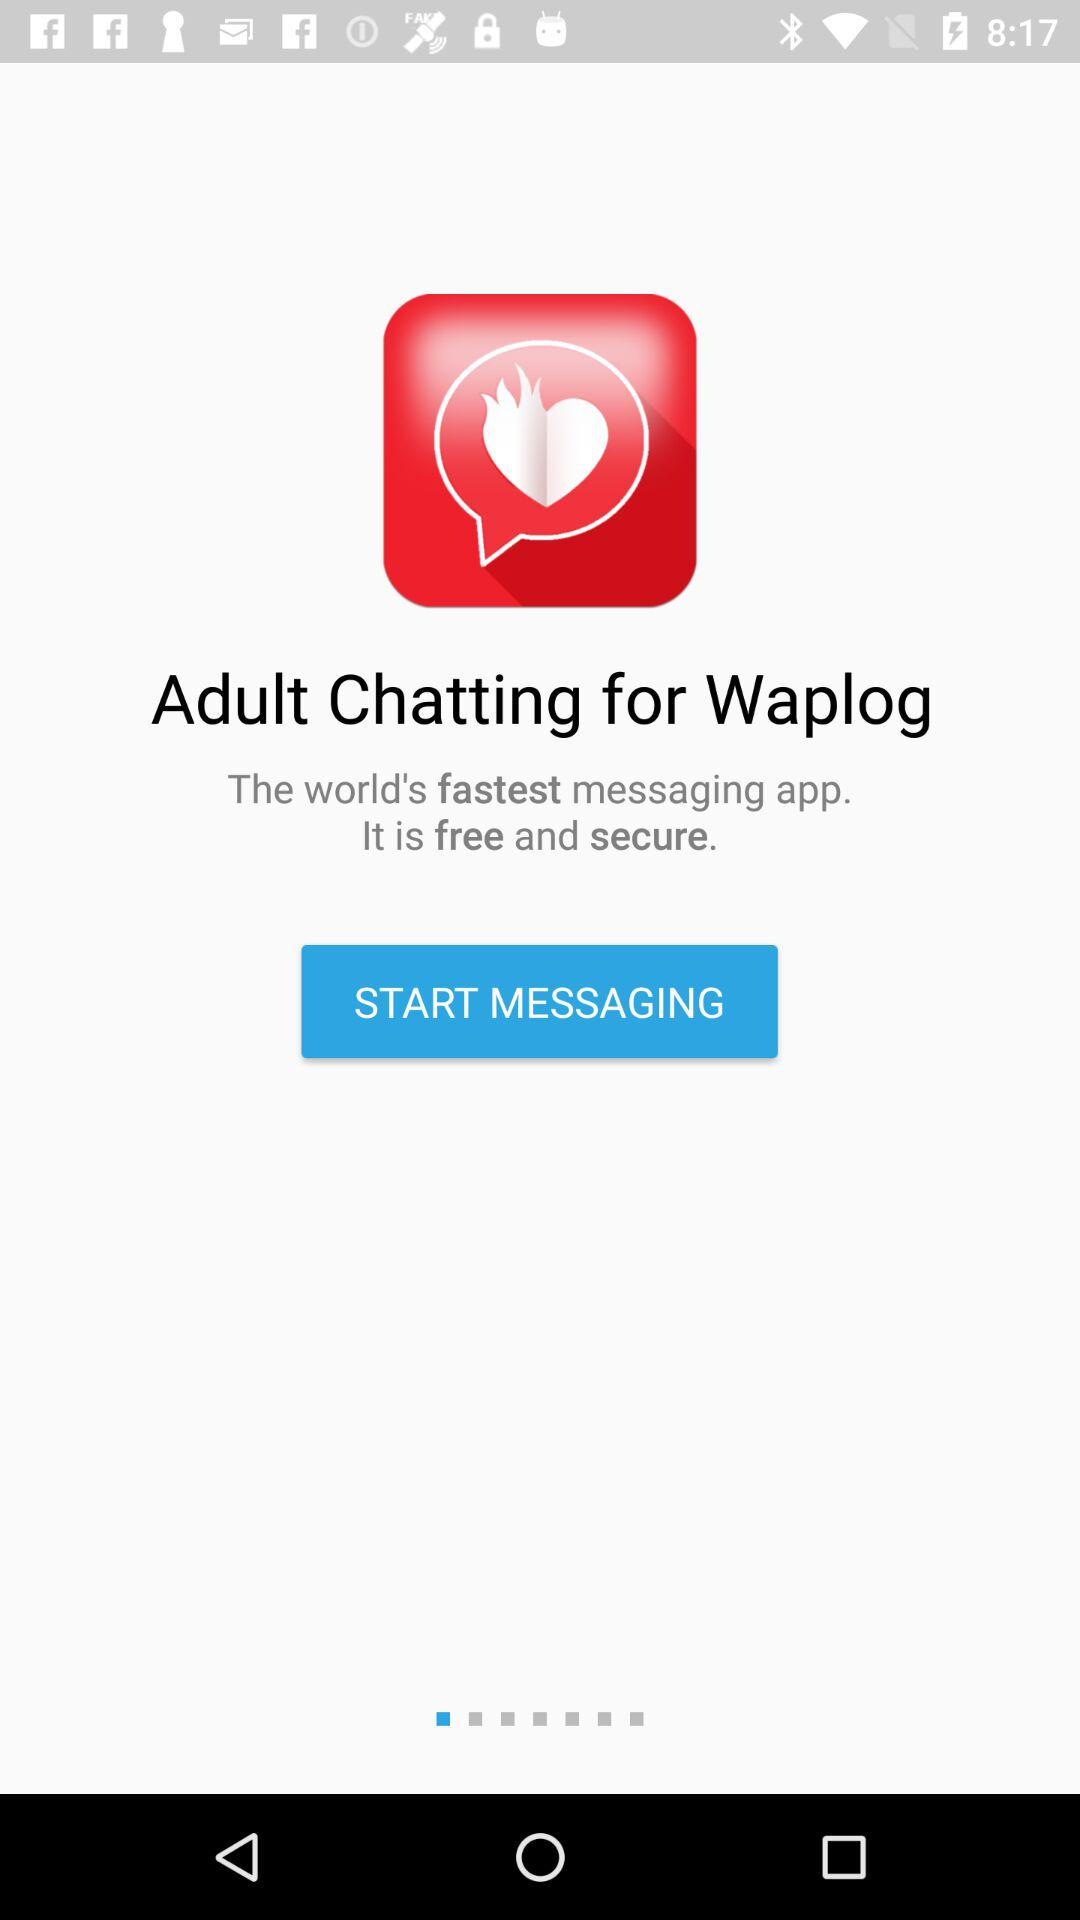What is the name of the application? The name of the application is "Waplog". 